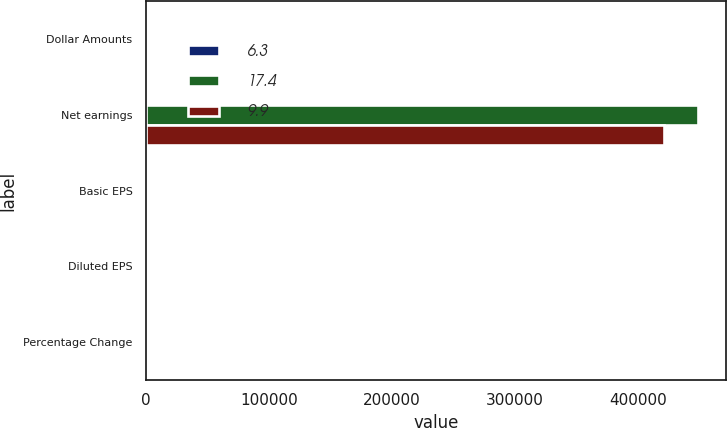<chart> <loc_0><loc_0><loc_500><loc_500><stacked_bar_chart><ecel><fcel>Dollar Amounts<fcel>Net earnings<fcel>Basic EPS<fcel>Diluted EPS<fcel>Percentage Change<nl><fcel>6.3<fcel>2014<fcel>2012<fcel>1.67<fcel>1.66<fcel>2014<nl><fcel>17.4<fcel>2013<fcel>448636<fcel>1.51<fcel>1.51<fcel>2013<nl><fcel>9.9<fcel>2012<fcel>420536<fcel>1.42<fcel>1.42<fcel>2012<nl></chart> 